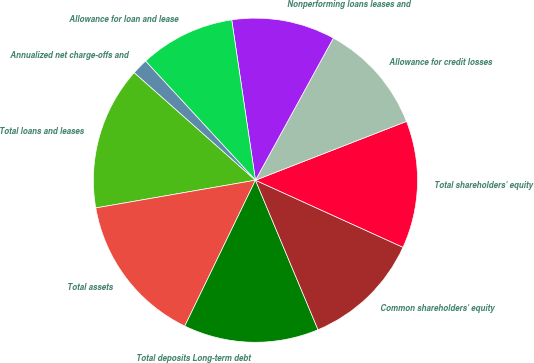Convert chart. <chart><loc_0><loc_0><loc_500><loc_500><pie_chart><fcel>Total loans and leases<fcel>Total assets<fcel>Total deposits Long-term debt<fcel>Common shareholders' equity<fcel>Total shareholders' equity<fcel>Allowance for credit losses<fcel>Nonperforming loans leases and<fcel>Allowance for loan and lease<fcel>Annualized net charge-offs and<nl><fcel>14.29%<fcel>15.08%<fcel>13.49%<fcel>11.9%<fcel>12.7%<fcel>11.11%<fcel>10.32%<fcel>9.52%<fcel>1.59%<nl></chart> 